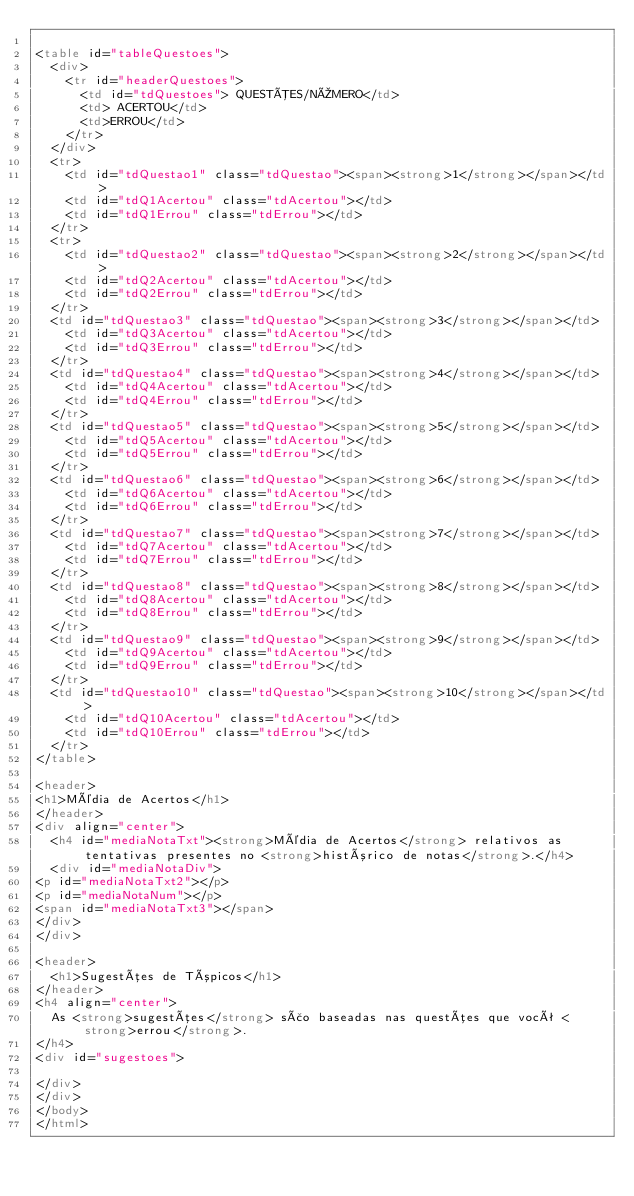Convert code to text. <code><loc_0><loc_0><loc_500><loc_500><_HTML_>
<table id="tableQuestoes">
  <div>
    <tr id="headerQuestoes">
      <td id="tdQuestoes"> QUESTÕES/NÚMERO</td>
      <td> ACERTOU</td>
      <td>ERROU</td>
    </tr>
  </div>
  <tr>
    <td id="tdQuestao1" class="tdQuestao"><span><strong>1</strong></span></td>
    <td id="tdQ1Acertou" class="tdAcertou"></td>
    <td id="tdQ1Errou" class="tdErrou"></td>
  </tr>
  <tr>
    <td id="tdQuestao2" class="tdQuestao"><span><strong>2</strong></span></td>
    <td id="tdQ2Acertou" class="tdAcertou"></td>
    <td id="tdQ2Errou" class="tdErrou"></td>
  </tr>
  <td id="tdQuestao3" class="tdQuestao"><span><strong>3</strong></span></td>
    <td id="tdQ3Acertou" class="tdAcertou"></td>
    <td id="tdQ3Errou" class="tdErrou"></td>
  </tr>
  <td id="tdQuestao4" class="tdQuestao"><span><strong>4</strong></span></td>
    <td id="tdQ4Acertou" class="tdAcertou"></td>
    <td id="tdQ4Errou" class="tdErrou"></td>
  </tr>
  <td id="tdQuestao5" class="tdQuestao"><span><strong>5</strong></span></td>
    <td id="tdQ5Acertou" class="tdAcertou"></td>
    <td id="tdQ5Errou" class="tdErrou"></td>
  </tr>
  <td id="tdQuestao6" class="tdQuestao"><span><strong>6</strong></span></td>
    <td id="tdQ6Acertou" class="tdAcertou"></td>
    <td id="tdQ6Errou" class="tdErrou"></td>
  </tr>
  <td id="tdQuestao7" class="tdQuestao"><span><strong>7</strong></span></td>
    <td id="tdQ7Acertou" class="tdAcertou"></td>
    <td id="tdQ7Errou" class="tdErrou"></td>
  </tr>
  <td id="tdQuestao8" class="tdQuestao"><span><strong>8</strong></span></td>
    <td id="tdQ8Acertou" class="tdAcertou"></td>
    <td id="tdQ8Errou" class="tdErrou"></td>
  </tr>
  <td id="tdQuestao9" class="tdQuestao"><span><strong>9</strong></span></td>
    <td id="tdQ9Acertou" class="tdAcertou"></td>
    <td id="tdQ9Errou" class="tdErrou"></td>
  </tr>
  <td id="tdQuestao10" class="tdQuestao"><span><strong>10</strong></span></td>
    <td id="tdQ10Acertou" class="tdAcertou"></td>
    <td id="tdQ10Errou" class="tdErrou"></td>
  </tr>
</table>

<header>
<h1>Média de Acertos</h1>
</header>
<div align="center">
  <h4 id="mediaNotaTxt"><strong>Média de Acertos</strong> relativos as tentativas presentes no <strong>histórico de notas</strong>.</h4>
  <div id="mediaNotaDiv">
<p id="mediaNotaTxt2"></p>
<p id="mediaNotaNum"></p>
<span id="mediaNotaTxt3"></span>
</div>
</div>

<header>
  <h1>Sugestões de Tópicos</h1>
</header>
<h4 align="center">
  As <strong>sugestões</strong> são baseadas nas questões que você <strong>errou</strong>.
</h4>
<div id="sugestoes">

</div>
</div>
</body>
</html></code> 